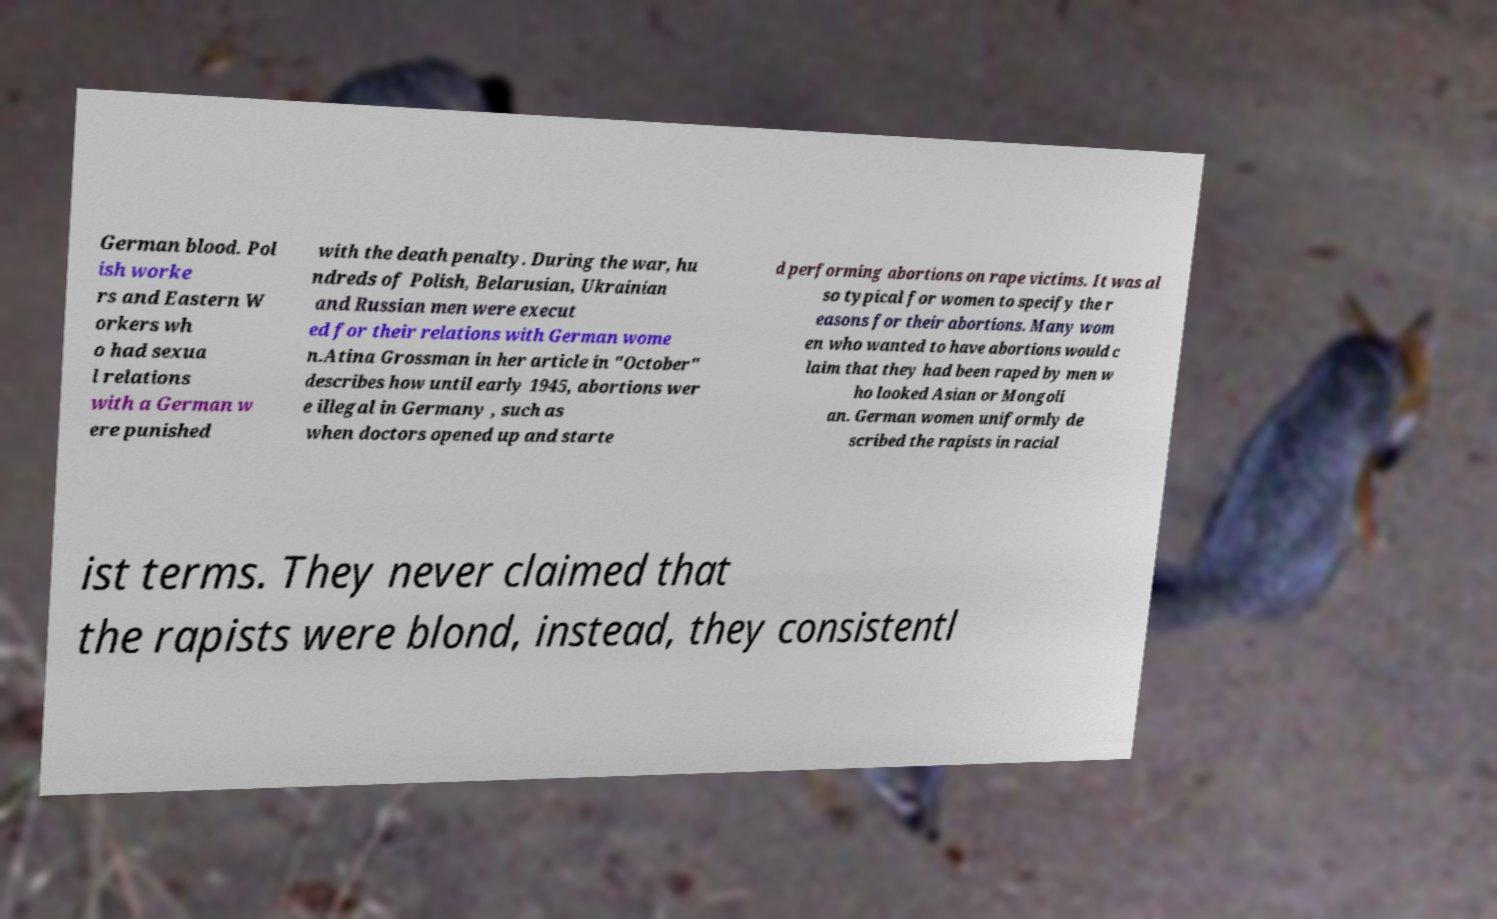Could you extract and type out the text from this image? German blood. Pol ish worke rs and Eastern W orkers wh o had sexua l relations with a German w ere punished with the death penalty. During the war, hu ndreds of Polish, Belarusian, Ukrainian and Russian men were execut ed for their relations with German wome n.Atina Grossman in her article in "October" describes how until early 1945, abortions wer e illegal in Germany , such as when doctors opened up and starte d performing abortions on rape victims. It was al so typical for women to specify the r easons for their abortions. Many wom en who wanted to have abortions would c laim that they had been raped by men w ho looked Asian or Mongoli an. German women uniformly de scribed the rapists in racial ist terms. They never claimed that the rapists were blond, instead, they consistentl 